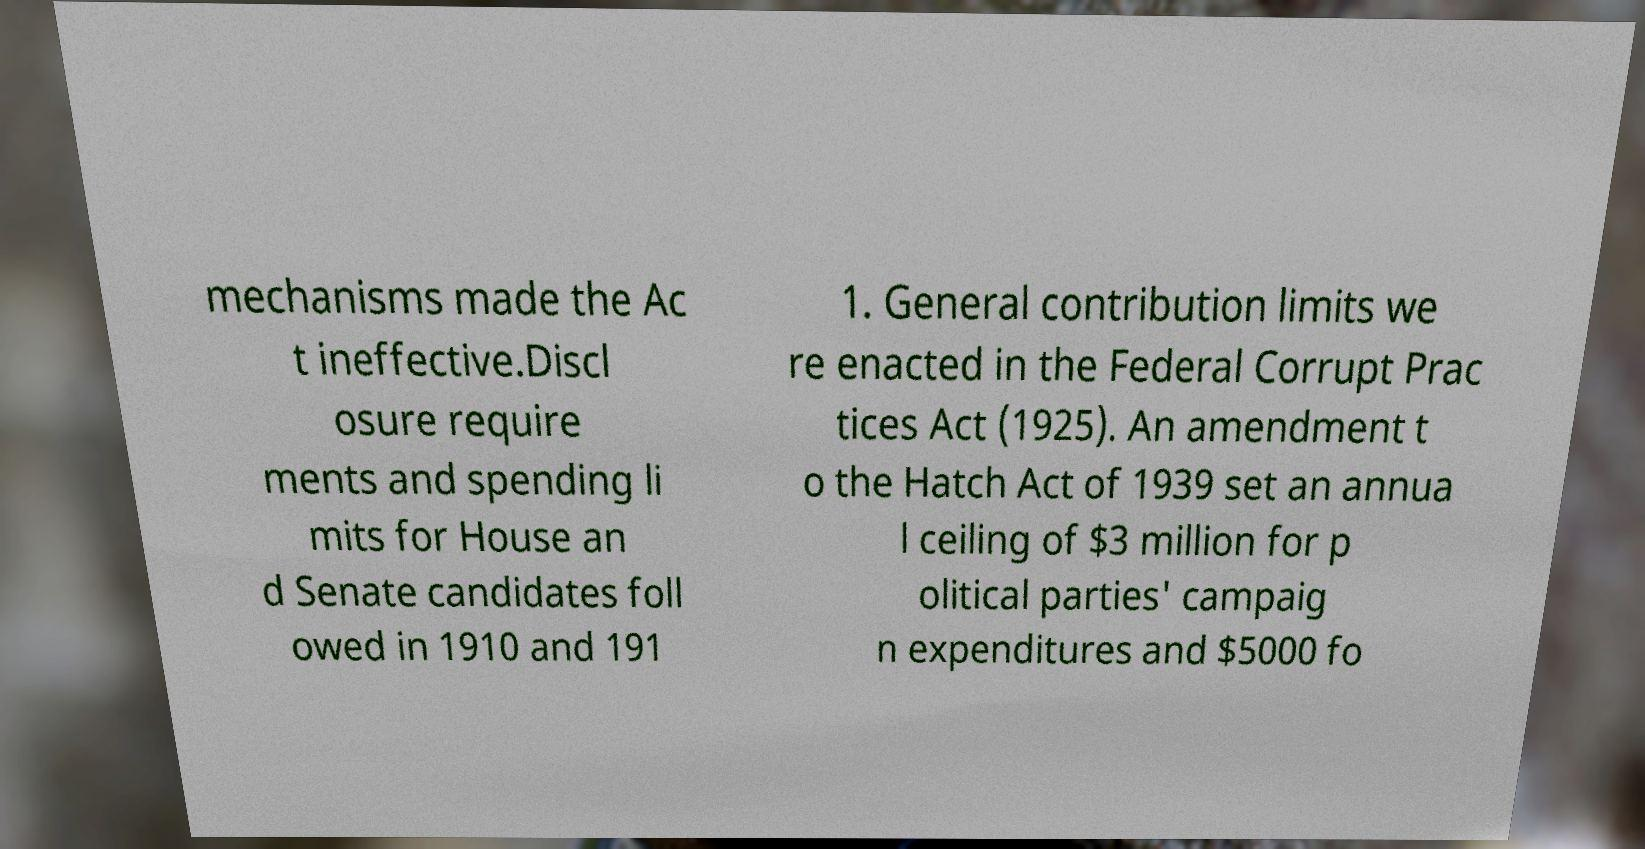For documentation purposes, I need the text within this image transcribed. Could you provide that? mechanisms made the Ac t ineffective.Discl osure require ments and spending li mits for House an d Senate candidates foll owed in 1910 and 191 1. General contribution limits we re enacted in the Federal Corrupt Prac tices Act (1925). An amendment t o the Hatch Act of 1939 set an annua l ceiling of $3 million for p olitical parties' campaig n expenditures and $5000 fo 